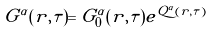<formula> <loc_0><loc_0><loc_500><loc_500>G ^ { \alpha } ( { r } , \tau ) = G ^ { \alpha } _ { 0 } ( { r } , \tau ) e ^ { Q ^ { \alpha } ( { r } , \tau ) }</formula> 